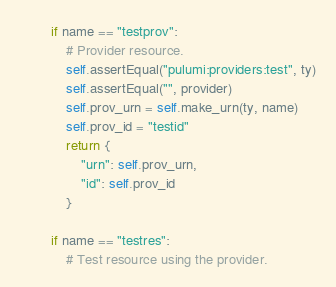<code> <loc_0><loc_0><loc_500><loc_500><_Python_>        if name == "testprov":
            # Provider resource.
            self.assertEqual("pulumi:providers:test", ty)
            self.assertEqual("", provider)
            self.prov_urn = self.make_urn(ty, name)
            self.prov_id = "testid"
            return {
                "urn": self.prov_urn,
                "id": self.prov_id
            }

        if name == "testres":
            # Test resource using the provider.</code> 